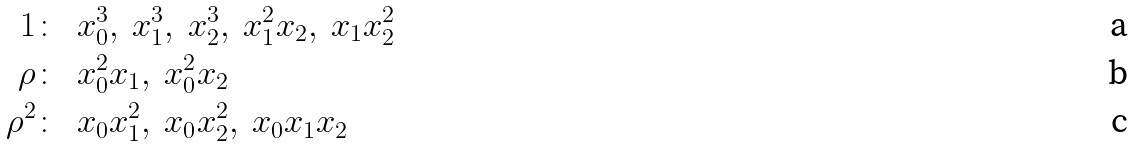Convert formula to latex. <formula><loc_0><loc_0><loc_500><loc_500>1 \colon & \ \ x _ { 0 } ^ { 3 } , \ x _ { 1 } ^ { 3 } , \ x _ { 2 } ^ { 3 } , \ x _ { 1 } ^ { 2 } x _ { 2 } , \ x _ { 1 } x _ { 2 } ^ { 2 } \\ \rho \colon & \ \ x _ { 0 } ^ { 2 } x _ { 1 } , \ x _ { 0 } ^ { 2 } x _ { 2 } \\ \rho ^ { 2 } \colon & \ \ x _ { 0 } x _ { 1 } ^ { 2 } , \ x _ { 0 } x _ { 2 } ^ { 2 } , \ x _ { 0 } x _ { 1 } x _ { 2 }</formula> 